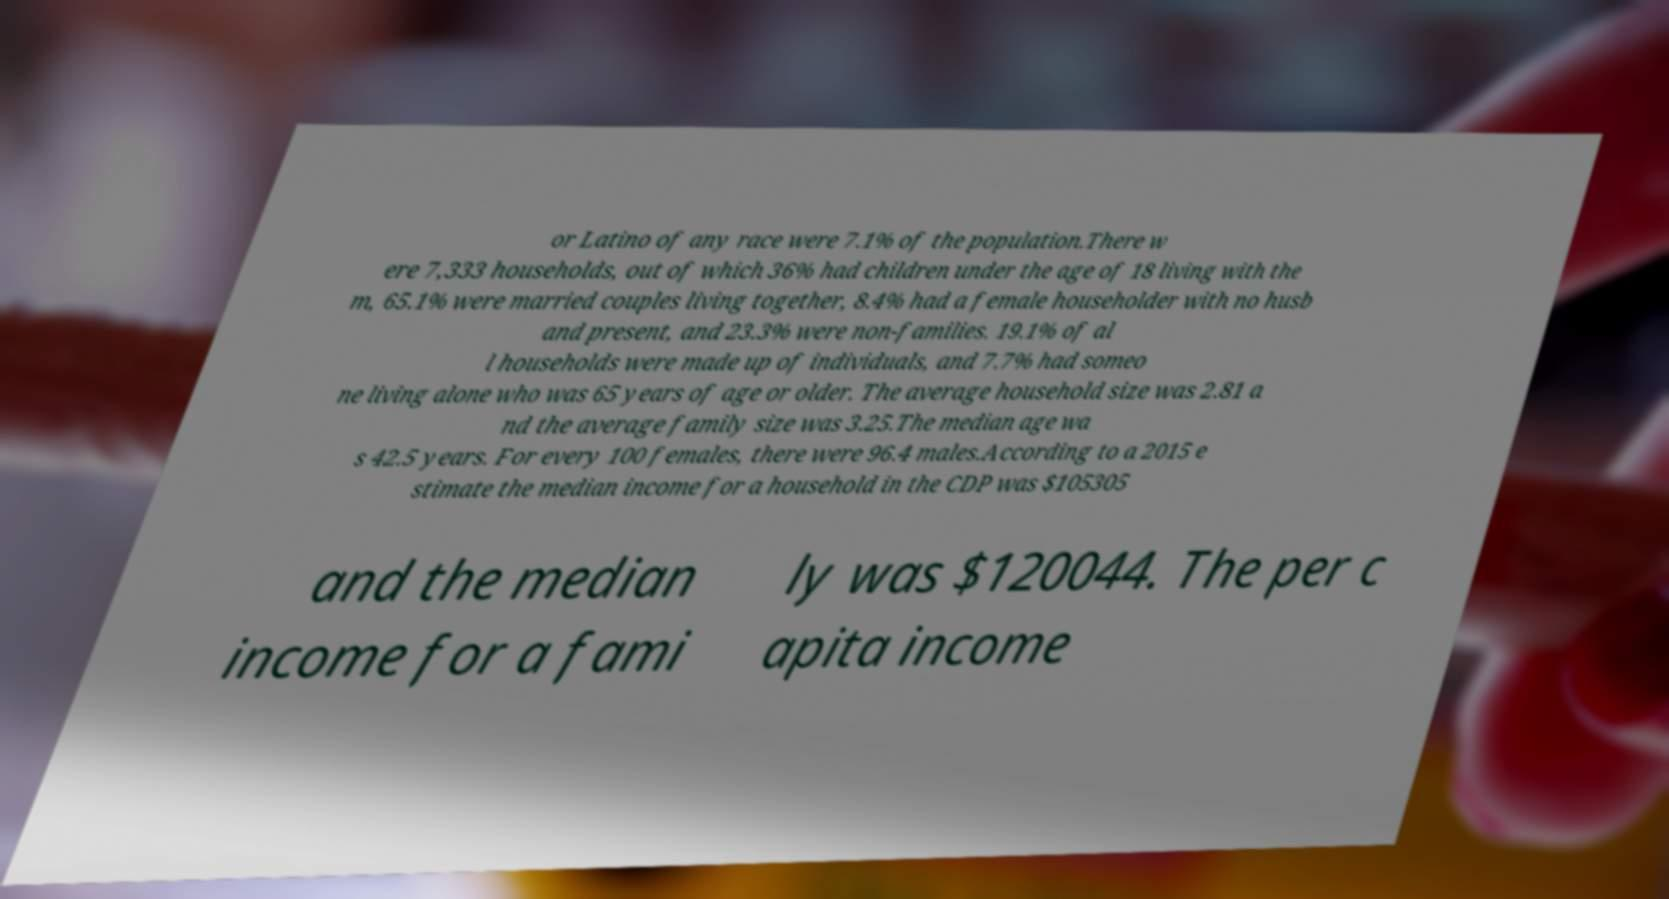Could you assist in decoding the text presented in this image and type it out clearly? or Latino of any race were 7.1% of the population.There w ere 7,333 households, out of which 36% had children under the age of 18 living with the m, 65.1% were married couples living together, 8.4% had a female householder with no husb and present, and 23.3% were non-families. 19.1% of al l households were made up of individuals, and 7.7% had someo ne living alone who was 65 years of age or older. The average household size was 2.81 a nd the average family size was 3.25.The median age wa s 42.5 years. For every 100 females, there were 96.4 males.According to a 2015 e stimate the median income for a household in the CDP was $105305 and the median income for a fami ly was $120044. The per c apita income 